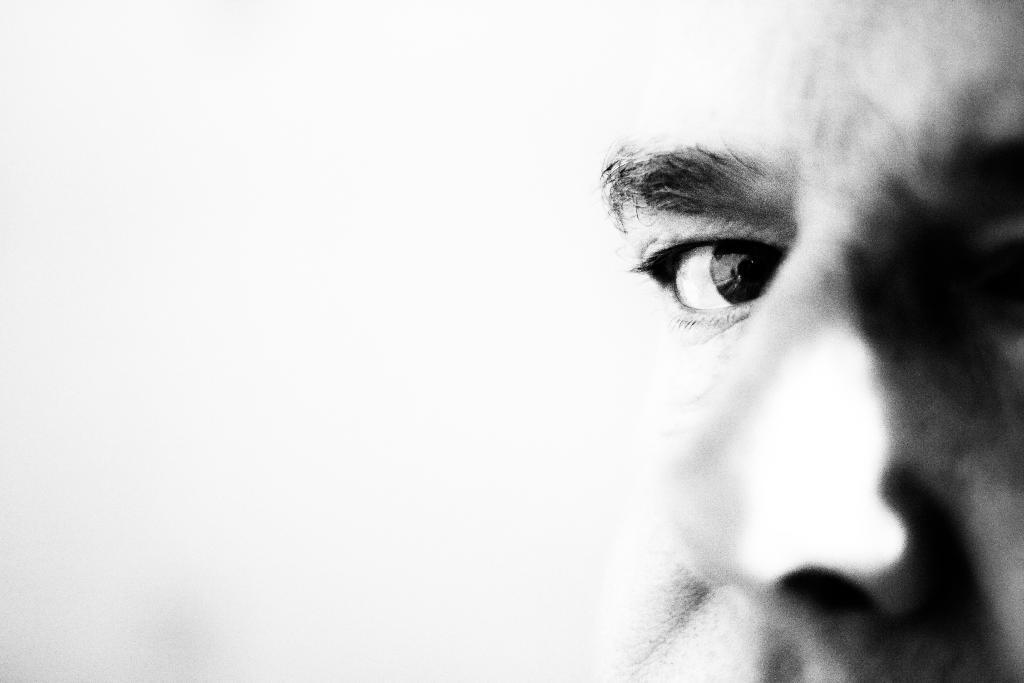Could you give a brief overview of what you see in this image? In this picture I can see there is a man at right side, I can see the eye, eyebrows and nose of the person. There is a white surface at left side and it is blurred. 